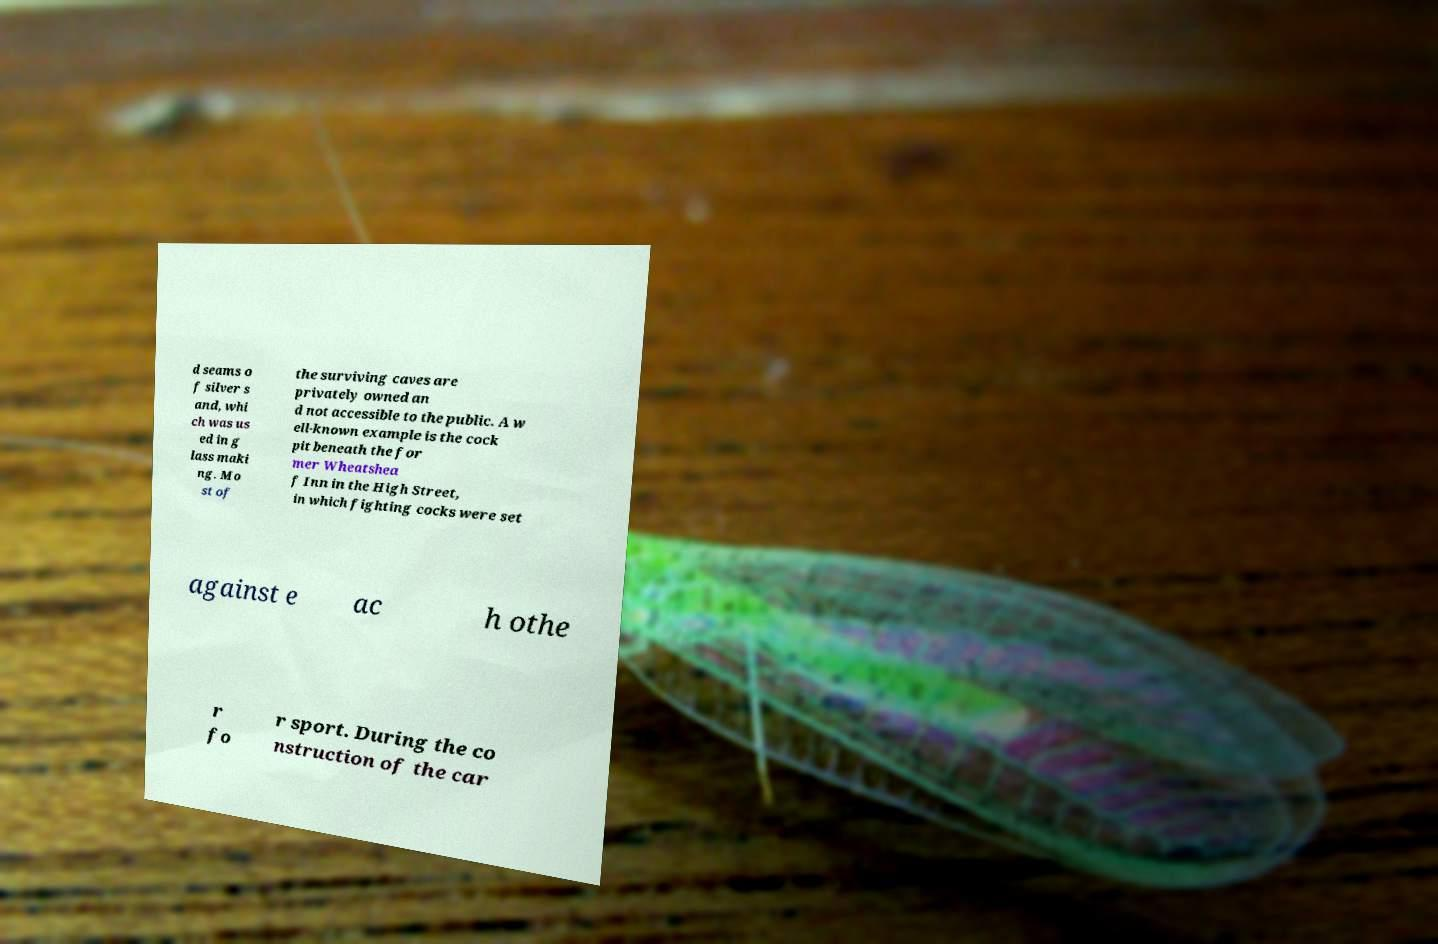For documentation purposes, I need the text within this image transcribed. Could you provide that? d seams o f silver s and, whi ch was us ed in g lass maki ng. Mo st of the surviving caves are privately owned an d not accessible to the public. A w ell-known example is the cock pit beneath the for mer Wheatshea f Inn in the High Street, in which fighting cocks were set against e ac h othe r fo r sport. During the co nstruction of the car 